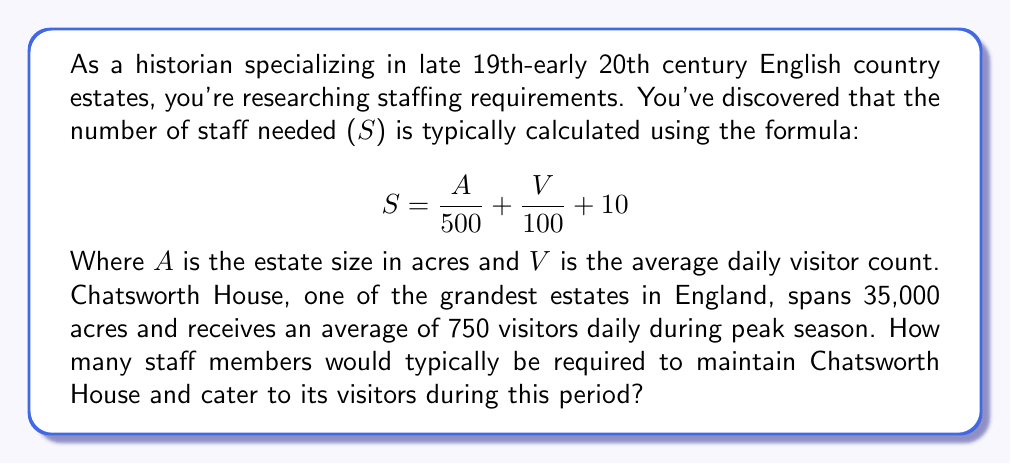Can you solve this math problem? To solve this problem, we'll use the given formula and substitute the known values:

$$S = \frac{A}{500} + \frac{V}{100} + 10$$

Where:
$A = 35,000$ acres (estate size of Chatsworth House)
$V = 750$ visitors (average daily visitor count)

Let's solve step by step:

1. Calculate $\frac{A}{500}$:
   $$\frac{35,000}{500} = 70$$

2. Calculate $\frac{V}{100}$:
   $$\frac{750}{100} = 7.5$$

3. Add the results from steps 1 and 2, then add 10:
   $$70 + 7.5 + 10 = 87.5$$

4. Since we can't have a fractional number of staff members, we round up to the nearest whole number:
   $$87.5 \approx 88$$

Therefore, Chatsworth House would typically require 88 staff members to maintain the estate and cater to visitors during peak season.
Answer: 88 staff members 